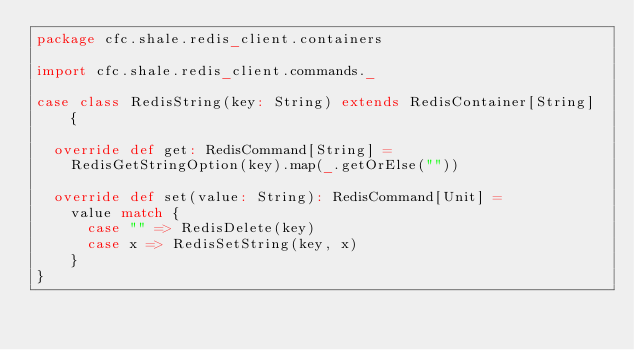Convert code to text. <code><loc_0><loc_0><loc_500><loc_500><_Scala_>package cfc.shale.redis_client.containers

import cfc.shale.redis_client.commands._

case class RedisString(key: String) extends RedisContainer[String] {

  override def get: RedisCommand[String] =
    RedisGetStringOption(key).map(_.getOrElse(""))

  override def set(value: String): RedisCommand[Unit] =
    value match {
      case "" => RedisDelete(key)
      case x => RedisSetString(key, x)
    }
}
</code> 